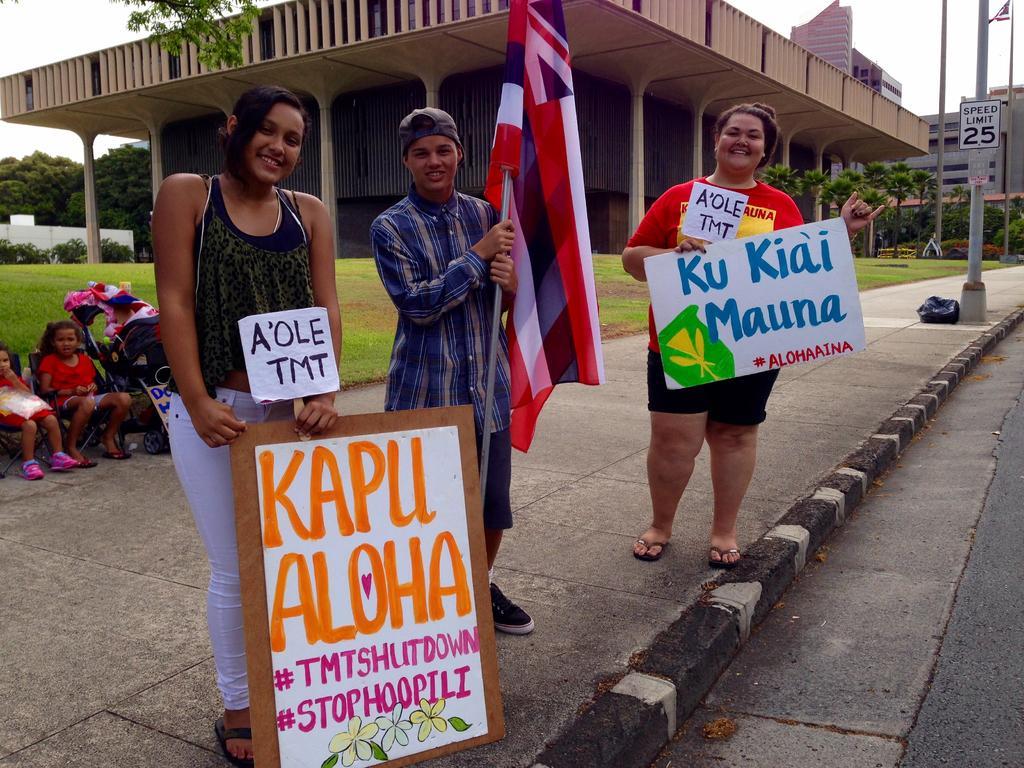Could you give a brief overview of what you see in this image? There are two woman, smiling, holding hoardings and standing on the footpath. In between them there is a boy, holding a flag, smiling and standing on the footpath. In the background, there are two children, sitting on chairs, there is a grass on the ground, there are buildings, trees and there is a sky. 